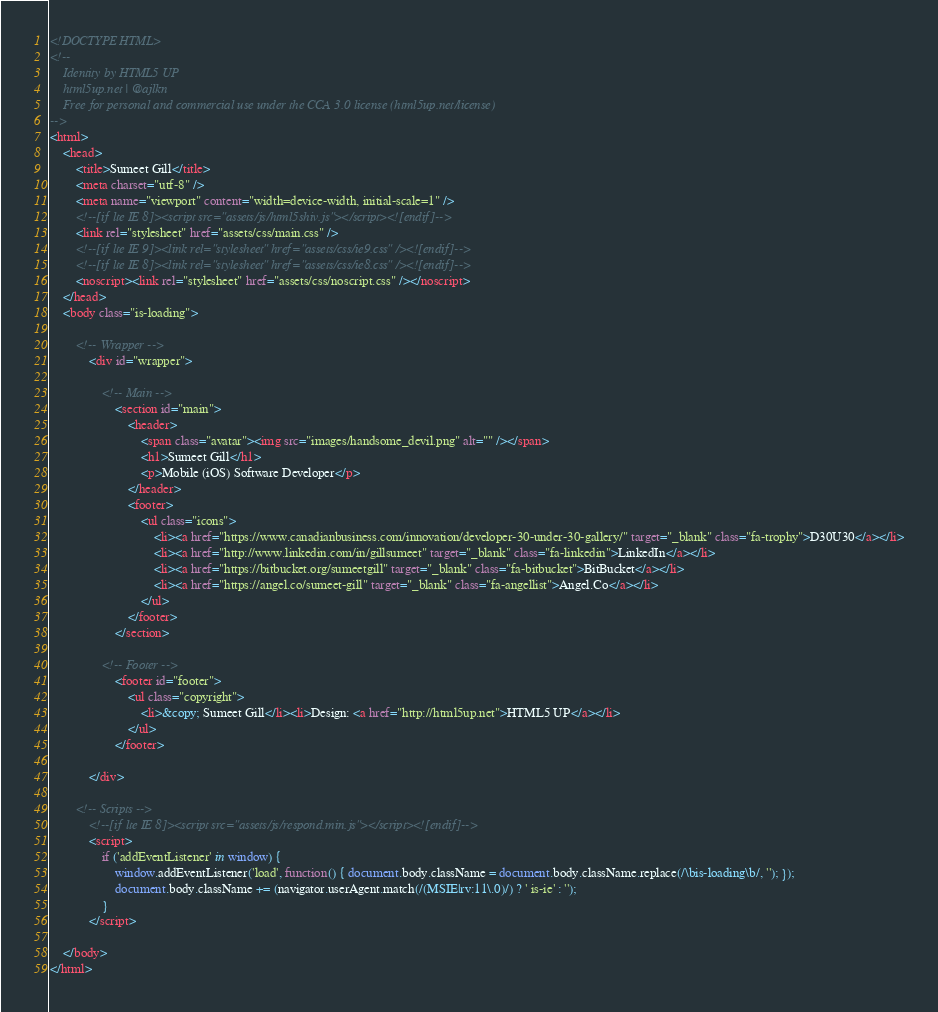<code> <loc_0><loc_0><loc_500><loc_500><_HTML_><!DOCTYPE HTML>
<!--
	Identity by HTML5 UP
	html5up.net | @ajlkn
	Free for personal and commercial use under the CCA 3.0 license (html5up.net/license)
-->
<html>
	<head>
		<title>Sumeet Gill</title>
		<meta charset="utf-8" />
		<meta name="viewport" content="width=device-width, initial-scale=1" />
		<!--[if lte IE 8]><script src="assets/js/html5shiv.js"></script><![endif]-->
		<link rel="stylesheet" href="assets/css/main.css" />
		<!--[if lte IE 9]><link rel="stylesheet" href="assets/css/ie9.css" /><![endif]-->
		<!--[if lte IE 8]><link rel="stylesheet" href="assets/css/ie8.css" /><![endif]-->
		<noscript><link rel="stylesheet" href="assets/css/noscript.css" /></noscript>
	</head>
	<body class="is-loading">

		<!-- Wrapper -->
			<div id="wrapper">

				<!-- Main -->
					<section id="main">
						<header>
							<span class="avatar"><img src="images/handsome_devil.png" alt="" /></span>
							<h1>Sumeet Gill</h1>
							<p>Mobile (iOS) Software Developer</p>
						</header>
						<footer>
							<ul class="icons">
								<li><a href="https://www.canadianbusiness.com/innovation/developer-30-under-30-gallery/" target="_blank" class="fa-trophy">D30U30</a></li>
								<li><a href="http://www.linkedin.com/in/gillsumeet" target="_blank" class="fa-linkedin">LinkedIn</a></li>
								<li><a href="https://bitbucket.org/sumeetgill" target="_blank" class="fa-bitbucket">BitBucket</a></li>
								<li><a href="https://angel.co/sumeet-gill" target="_blank" class="fa-angellist">Angel.Co</a></li>
							</ul>
						</footer>
					</section>

				<!-- Footer -->
					<footer id="footer">
						<ul class="copyright">
							<li>&copy; Sumeet Gill</li><li>Design: <a href="http://html5up.net">HTML5 UP</a></li>
						</ul>
					</footer>

			</div>

		<!-- Scripts -->
			<!--[if lte IE 8]><script src="assets/js/respond.min.js"></script><![endif]-->
			<script>
				if ('addEventListener' in window) {
					window.addEventListener('load', function() { document.body.className = document.body.className.replace(/\bis-loading\b/, ''); });
					document.body.className += (navigator.userAgent.match(/(MSIE|rv:11\.0)/) ? ' is-ie' : '');
				}
			</script>

	</body>
</html>
</code> 